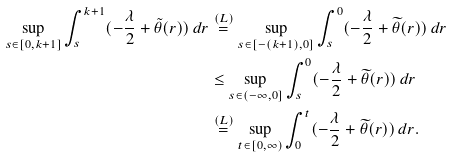<formula> <loc_0><loc_0><loc_500><loc_500>\sup _ { s \in [ 0 , k + 1 ] } \int _ { s } ^ { k + 1 } ( - \frac { \lambda } { 2 } + \tilde { \theta } ( r ) ) \, d r & \overset { ( L ) } { = } \sup _ { s \in [ - ( k + 1 ) , 0 ] } \int _ { s } ^ { 0 } ( - \frac { \lambda } { 2 } + \widetilde { \theta } ( r ) ) \, d r \\ & \leq \sup _ { s \in ( - \infty , 0 ] } \int _ { s } ^ { 0 } ( - \frac { \lambda } { 2 } + \widetilde { \theta } ( r ) ) \, d r \\ & \overset { ( L ) } { = } \sup _ { t \in [ 0 , \infty ) } \int _ { 0 } ^ { t } ( - \frac { \lambda } { 2 } + \widetilde { \theta } ( r ) ) \, d r .</formula> 